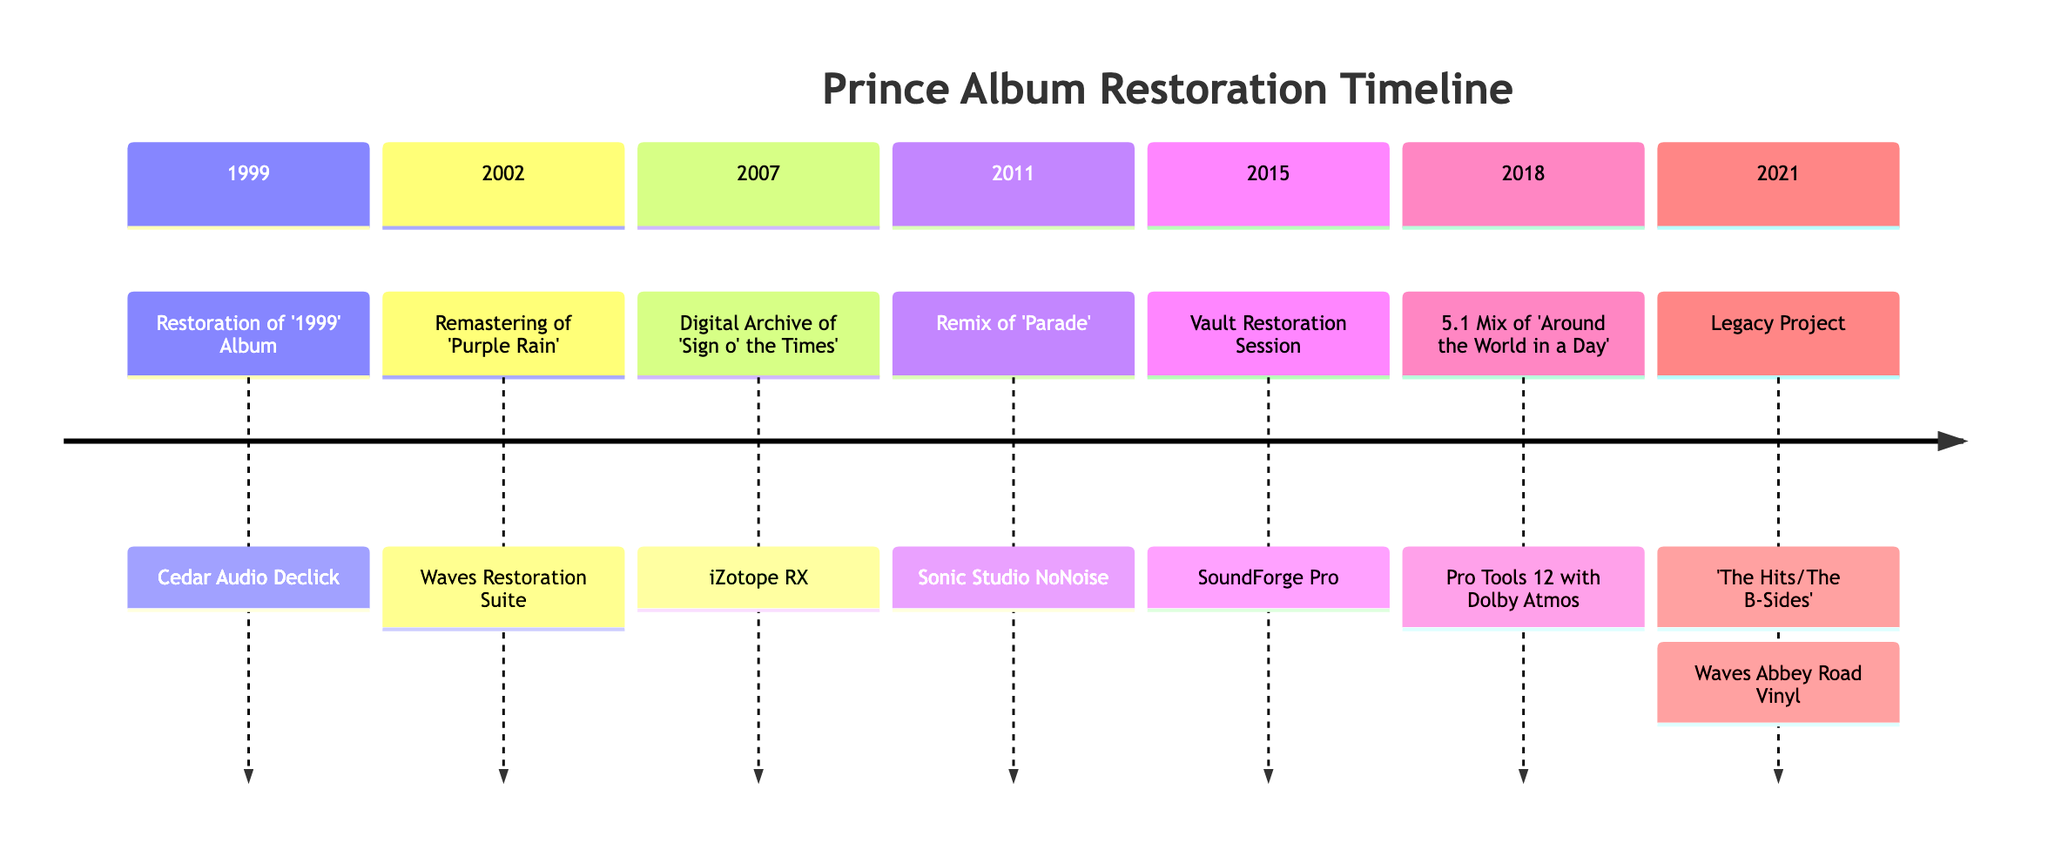What technology was used for the restoration of '1999' Album? The diagram shows that the technology used for the restoration of '1999' Album in 1999 was Cedar Audio Declick.
Answer: Cedar Audio Declick In which year was the remix of 'Parade' completed? By following the timeline in the diagram, the remix of 'Parade' was completed in 2011.
Answer: 2011 How many restoration projects were completed before 2015? The timeline indicates there are four projects (1999, 2002, 2007, and 2011) completed before 2015.
Answer: 4 What is the last project mentioned in the timeline? Identifying the last project in the diagram, the last project mentioned is the 'Legacy Project: The Hits/The B-Sides' completed in 2021.
Answer: Legacy Project: 'The Hits/The B-Sides' What technology was used for the 5.1 Mix of 'Around the World in a Day'? The diagram indicates that the technology used for the 5.1 Mix of 'Around the World in a Day' in 2018 was Pro Tools 12 with Dolby Atmos.
Answer: Pro Tools 12 with Dolby Atmos Which project utilized iZotope RX for restoration? According to the diagram, the Digital Archive of 'Sign o' the Times' completed in 2007 utilized iZotope RX for restoration.
Answer: Digital Archive of 'Sign o' the Times' What was the primary goal of the Vault Restoration Session? The timeline shows that the goal of the Vault Restoration Session in 2015 was to restore previously unreleased tracks from Prince's vault.
Answer: Restore previously unreleased tracks What type of processing was used for the Legacy Project? The diagram describes that the Waves Abbey Road Vinyl technology was used to emulate original analog warmth while correcting pops and distortions in the Legacy Project.
Answer: Emulate original analog warmth What is the earliest restoration project listed in the timeline? Examining the timeline, it is clear that the earliest restoration project is the restoration of '1999' Album, which took place in 1999.
Answer: Restoration of '1999' Album 